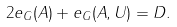Convert formula to latex. <formula><loc_0><loc_0><loc_500><loc_500>2 e _ { G } ( A ) + e _ { G } ( A , U ) = D .</formula> 